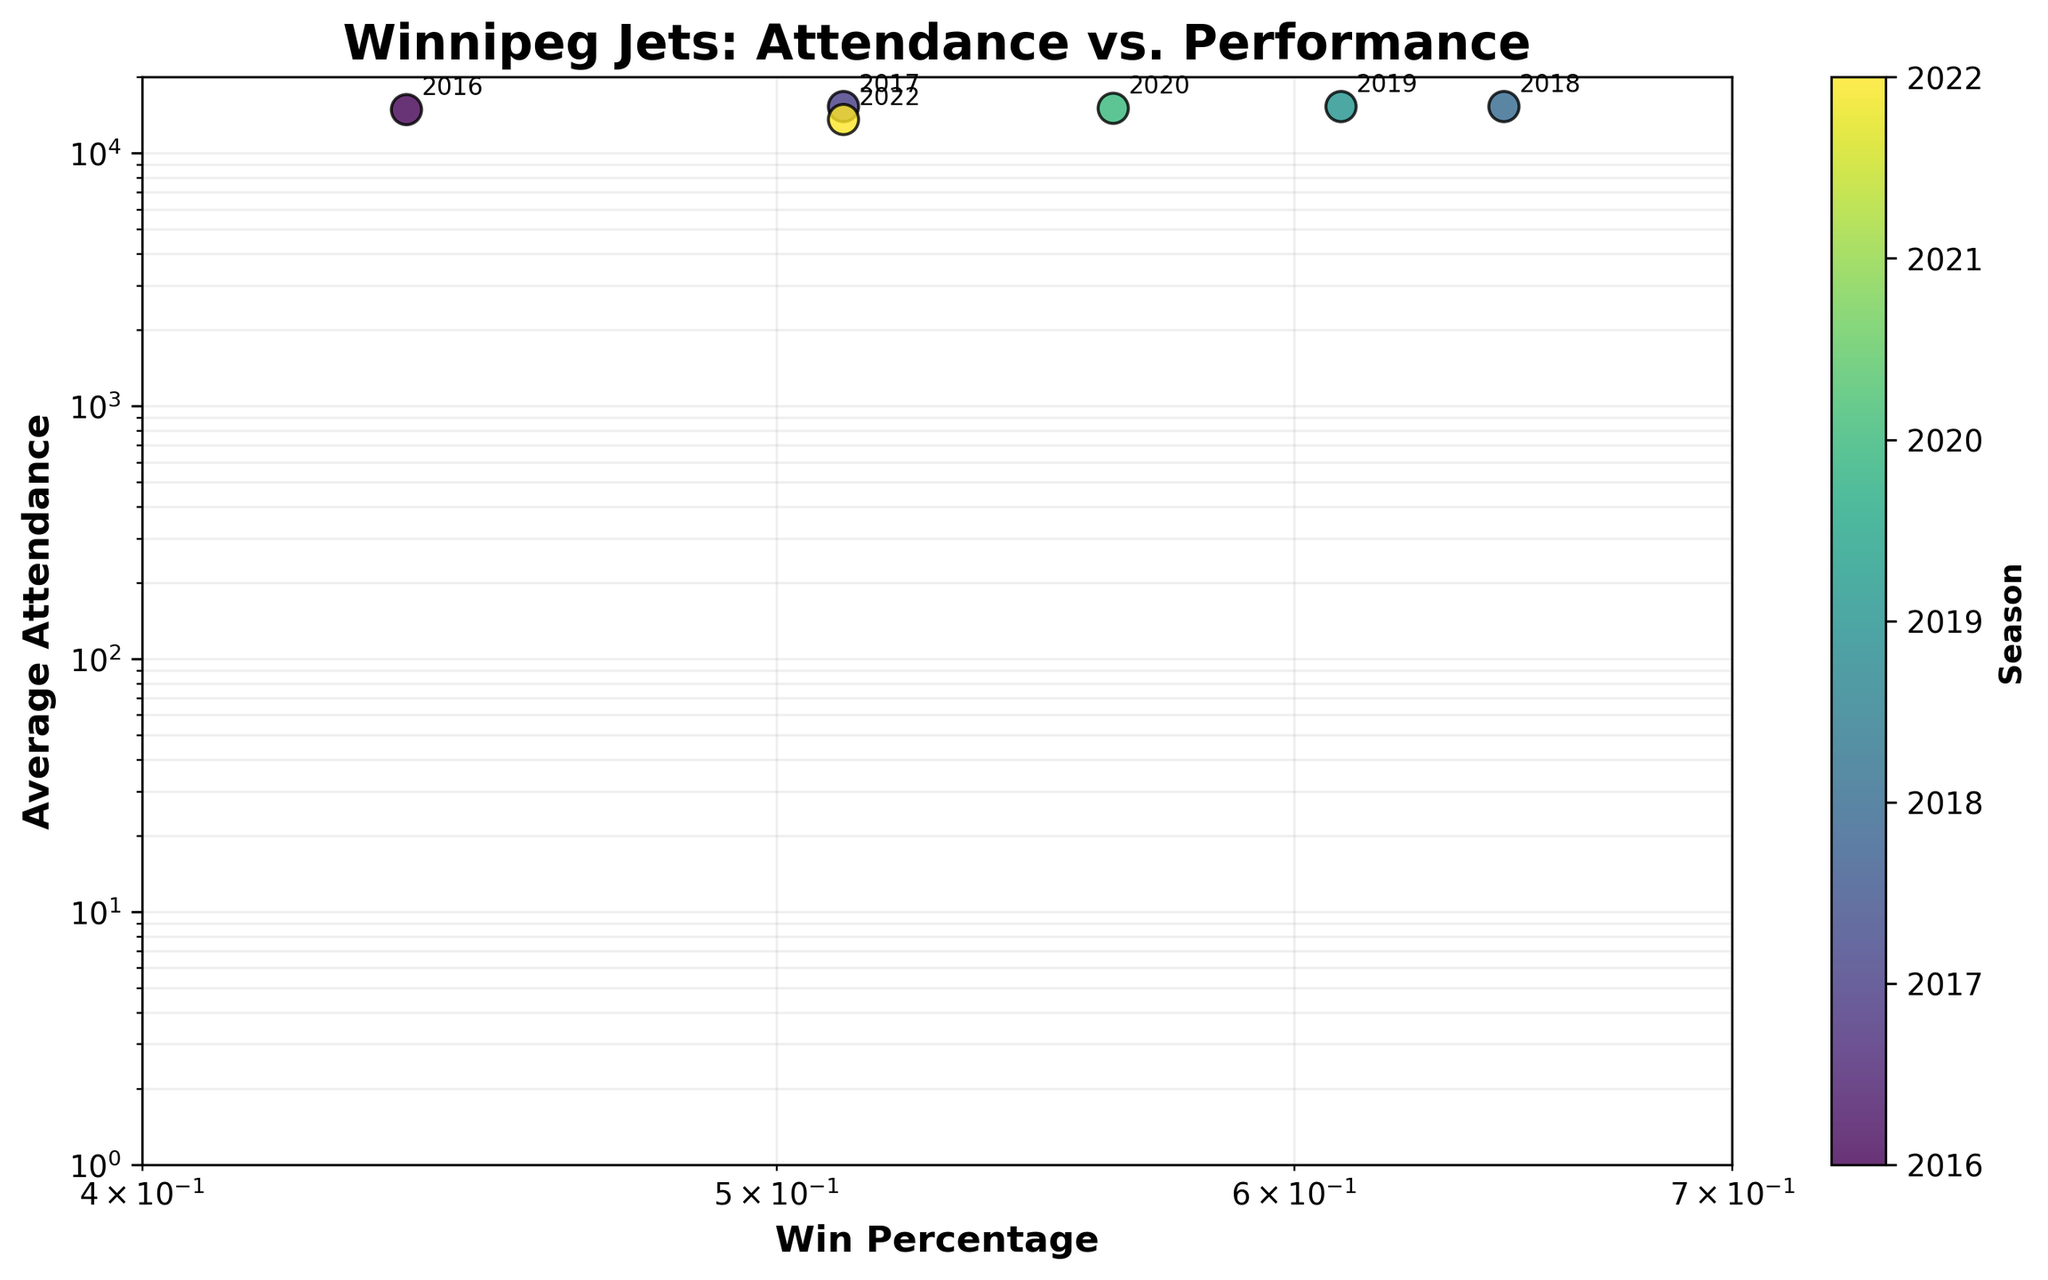What's the title of the scatter plot? The title of the scatter plot is prominently displayed at the top in bold text.
Answer: Winnipeg Jets: Attendance vs. Performance How many seasons are represented in the scatter plot? Each point on the scatter plot represents a season, and there are labels or annotations for each point. By counting them, we see there are 7 different seasons.
Answer: 7 In which season did the Winnipeg Jets have the highest average attendance? The y-axis represents the average attendance, and the highest point along the y-axis indicates the highest attendance. By checking the annotated labels, we find that the 2017, 2018, and 2019 seasons had the highest average attendance of 15,294.
Answer: 2017, 2018, 2019 Which season had zero average attendance, and what could be the possible reason for this? By looking at the data points along the y-axis and the annotations, we can see that the 2021 season had an average attendance of zero. This is possibly due to the COVID-19 pandemic restrictions.
Answer: 2021, COVID-19 restrictions Compare the win percentages and average attendances for the 2016 and 2018 seasons. Which season had a higher win percentage, and which had a higher average attendance? By referencing the data points for the annotated years, 2016 had a win percentage of 0.439 and an average attendance of 14,870, whereas 2018 had a win percentage of 0.646 with an average attendance of 15,294. 2018 had both a higher win percentage and higher average attendance.
Answer: 2018 for both win percentage and average attendance What trend can be observed between the Winnipeg Jets’ win percentage and average attendance from 2016 to 2022? Observing the scatter plot’s points and their positions across the years, a general trend shows that higher win percentages tend to correlate with higher average attendance, except for anomalies like the 2021 season.
Answer: Higher win percentage usually correlates with higher attendance Which season shows a notable drop in average attendance apart from the 2021 season? By looking at the position of the points on the y-axis and their respective annotations, it’s clear that the 2022 season had a notable drop in average attendance compared to previous seasons.
Answer: 2022 Is there a correlation between win percentage and average attendance based on the scatter plot? While directly observing the position of points, seasons with higher win percentages generally tend to have higher average attendance values, suggesting a positive correlation.
Answer: Yes, positive correlation What is the win percentage range of the Winnipeg Jets between 2016 and 2022? We look at the lowest and highest points on the x-axis where the annotated seasons lie. The lowest win percentage is from 2016 (0.439) and the highest from 2018 (0.646).
Answer: 0.439 to 0.646 What is the visual effect of the log scale on the perception of win percentages and average attendances in the scatter plot? The log scale compresses large ranges into a smaller visual space, making exponential differences appear more linear and easier to compare at a glance. It helps in observing trends and relationships more effectively when the data spans wide ranges.
Answer: Compresses large ranges, makes exponential differences linear 